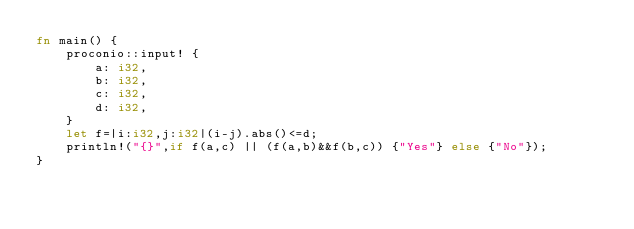Convert code to text. <code><loc_0><loc_0><loc_500><loc_500><_Rust_>fn main() {
    proconio::input! {
        a: i32,
        b: i32,
        c: i32,
        d: i32,
    }
    let f=|i:i32,j:i32|(i-j).abs()<=d;
    println!("{}",if f(a,c) || (f(a,b)&&f(b,c)) {"Yes"} else {"No"});
}</code> 